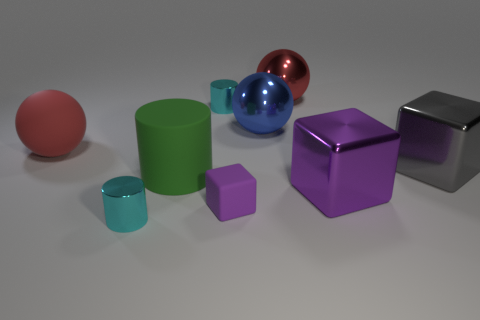Add 1 red metallic spheres. How many objects exist? 10 Subtract all cubes. How many objects are left? 6 Add 7 large purple blocks. How many large purple blocks exist? 8 Subtract 2 cyan cylinders. How many objects are left? 7 Subtract all big red rubber spheres. Subtract all blue objects. How many objects are left? 7 Add 4 large purple metal things. How many large purple metal things are left? 5 